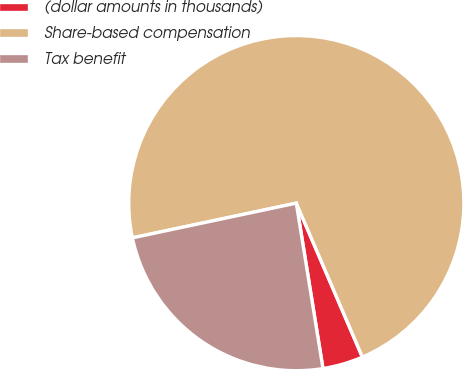Convert chart to OTSL. <chart><loc_0><loc_0><loc_500><loc_500><pie_chart><fcel>(dollar amounts in thousands)<fcel>Share-based compensation<fcel>Tax benefit<nl><fcel>3.91%<fcel>71.87%<fcel>24.22%<nl></chart> 